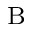<formula> <loc_0><loc_0><loc_500><loc_500>_ { B }</formula> 